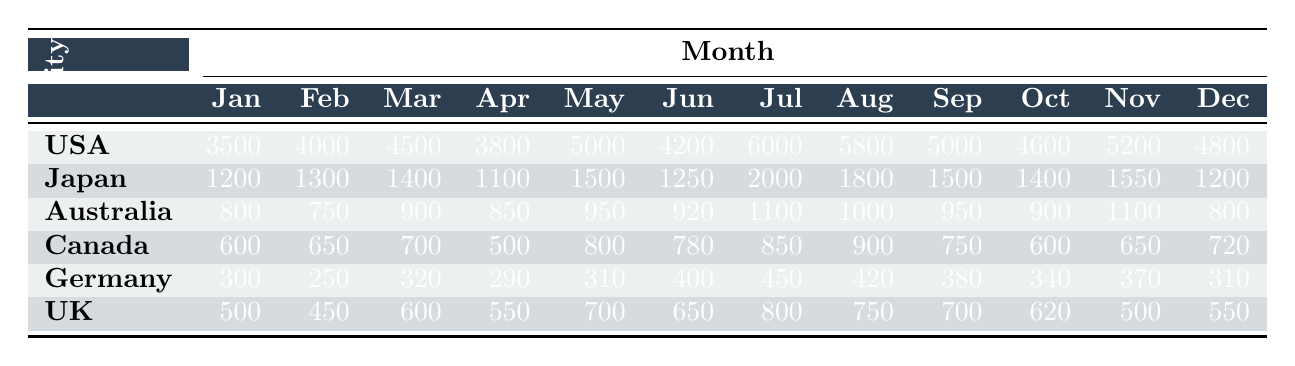What was the total number of visitors from Japan in August and July combined? To find the total number of visitors from Japan in August and July, I need to look at the values for these months. In July, there were 2000 visitors from Japan, and in August, there were 1800 visitors. Adding these together gives 2000 + 1800 = 3800.
Answer: 3800 Which month had the highest number of visitors from Canada? I will check the numbers of Canadian visitors for each month. The highest value appears in August with 900 visitors, which is more than any other month listed.
Answer: August Did the number of visitors from the UK increase more from June to July or from July to August? First, I'll determine the number of UK visitors in July and August. In June, there were 650 UK visitors, and in July, there were 800 (an increase of 150). In August, there were 750 UK visitors (a decrease of 50). Therefore, the increase from June to July is 150, while there was a decrease from July to August. The largest change was from June to July, which was an increase.
Answer: June to July What was the average number of visitors from Australia across the entire year? I will sum the number of visitors from Australia each month and then divide by 12. The total for Australia is 800 + 750 + 900 + 850 + 950 + 920 + 1100 + 1000 + 950 + 900 + 1100 + 800 = 11120. Dividing this sum (11120) by 12 gives an average of 926.67, rounded to 927 for simplicity.
Answer: 927 Is it true that more American visitors came in July than in any other month? By checking the values for American visitors across all months, July does show the highest number with 6000 visitors. This is confirmed by the values of the other months, which do not exceed this figure. Hence, it is true that July had the most American visitors.
Answer: Yes 